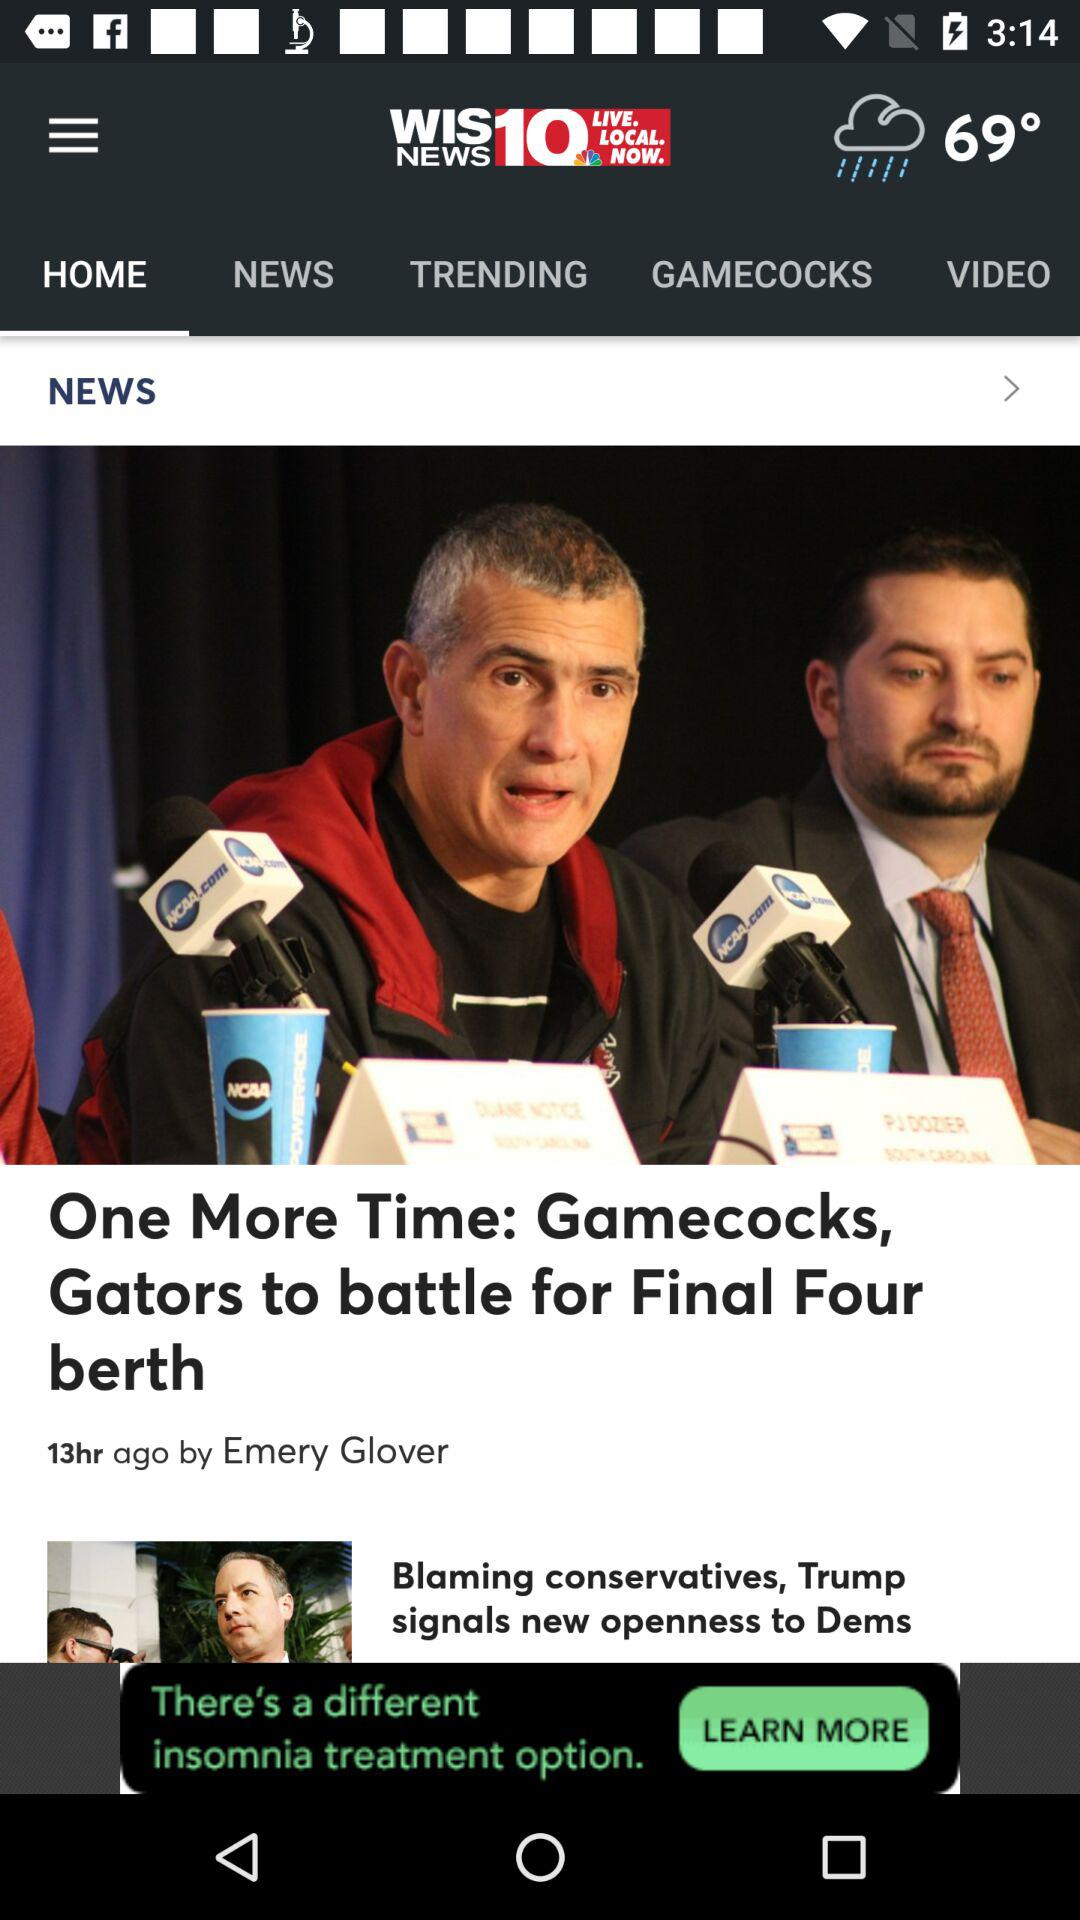Which tab is selected? The tab "HOME" is selected. 